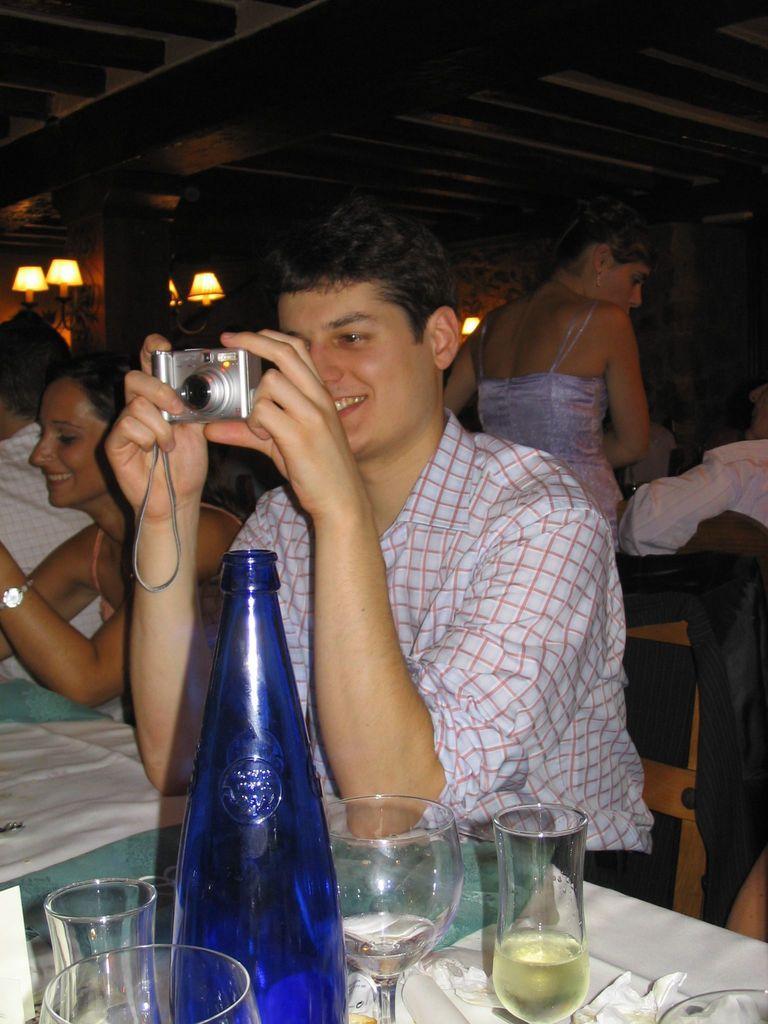Can you describe this image briefly? This picture shows a man sitting on the chair with a smile on his face and he holds the camera in his hand and we see a water bottle and few glasses on the table and we see few people seated and a woman standing on his back. 